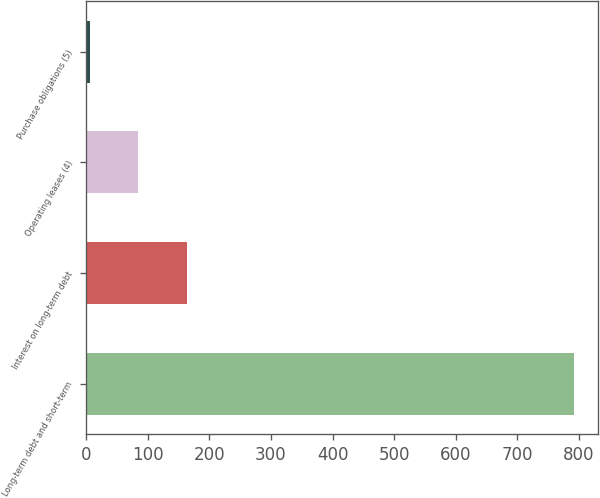Convert chart to OTSL. <chart><loc_0><loc_0><loc_500><loc_500><bar_chart><fcel>Long-term debt and short-term<fcel>Interest on long-term debt<fcel>Operating leases (4)<fcel>Purchase obligations (5)<nl><fcel>792<fcel>163.2<fcel>84.6<fcel>6<nl></chart> 